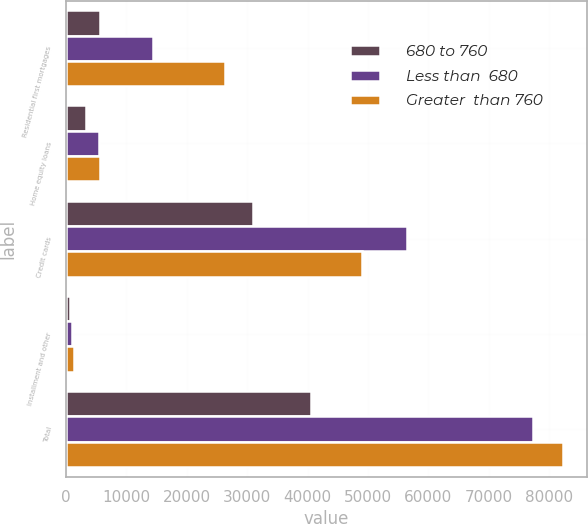<chart> <loc_0><loc_0><loc_500><loc_500><stacked_bar_chart><ecel><fcel>Residential first mortgages<fcel>Home equity loans<fcel>Credit cards<fcel>Installment and other<fcel>Total<nl><fcel>680 to 760<fcel>5603<fcel>3347<fcel>30875<fcel>716<fcel>40541<nl><fcel>Less than  680<fcel>14423<fcel>5439<fcel>56443<fcel>1020<fcel>77325<nl><fcel>Greater  than 760<fcel>26271<fcel>5650<fcel>48989<fcel>1275<fcel>82185<nl></chart> 